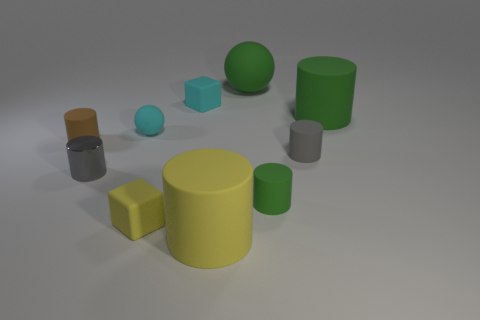Subtract all big matte cylinders. How many cylinders are left? 4 Subtract all brown cylinders. How many cylinders are left? 5 Subtract 3 cylinders. How many cylinders are left? 3 Subtract all green cylinders. Subtract all gray blocks. How many cylinders are left? 4 Subtract all cylinders. How many objects are left? 4 Add 7 large cyan cubes. How many large cyan cubes exist? 7 Subtract 0 blue spheres. How many objects are left? 10 Subtract all blocks. Subtract all tiny cyan things. How many objects are left? 6 Add 2 rubber cylinders. How many rubber cylinders are left? 7 